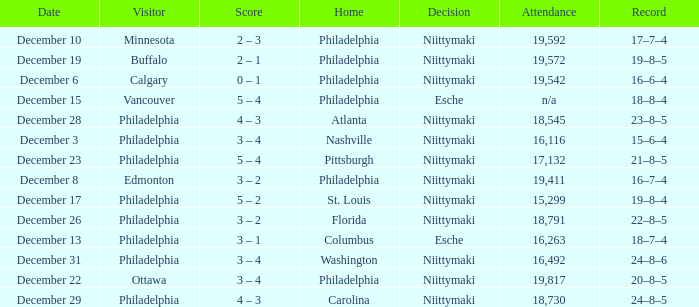Can you parse all the data within this table? {'header': ['Date', 'Visitor', 'Score', 'Home', 'Decision', 'Attendance', 'Record'], 'rows': [['December 10', 'Minnesota', '2 – 3', 'Philadelphia', 'Niittymaki', '19,592', '17–7–4'], ['December 19', 'Buffalo', '2 – 1', 'Philadelphia', 'Niittymaki', '19,572', '19–8–5'], ['December 6', 'Calgary', '0 – 1', 'Philadelphia', 'Niittymaki', '19,542', '16–6–4'], ['December 15', 'Vancouver', '5 – 4', 'Philadelphia', 'Esche', 'n/a', '18–8–4'], ['December 28', 'Philadelphia', '4 – 3', 'Atlanta', 'Niittymaki', '18,545', '23–8–5'], ['December 3', 'Philadelphia', '3 – 4', 'Nashville', 'Niittymaki', '16,116', '15–6–4'], ['December 23', 'Philadelphia', '5 – 4', 'Pittsburgh', 'Niittymaki', '17,132', '21–8–5'], ['December 8', 'Edmonton', '3 – 2', 'Philadelphia', 'Niittymaki', '19,411', '16–7–4'], ['December 17', 'Philadelphia', '5 – 2', 'St. Louis', 'Niittymaki', '15,299', '19–8–4'], ['December 26', 'Philadelphia', '3 – 2', 'Florida', 'Niittymaki', '18,791', '22–8–5'], ['December 13', 'Philadelphia', '3 – 1', 'Columbus', 'Esche', '16,263', '18–7–4'], ['December 31', 'Philadelphia', '3 – 4', 'Washington', 'Niittymaki', '16,492', '24–8–6'], ['December 22', 'Ottawa', '3 – 4', 'Philadelphia', 'Niittymaki', '19,817', '20–8–5'], ['December 29', 'Philadelphia', '4 – 3', 'Carolina', 'Niittymaki', '18,730', '24–8–5']]} What was the decision when the attendance was 19,592? Niittymaki. 